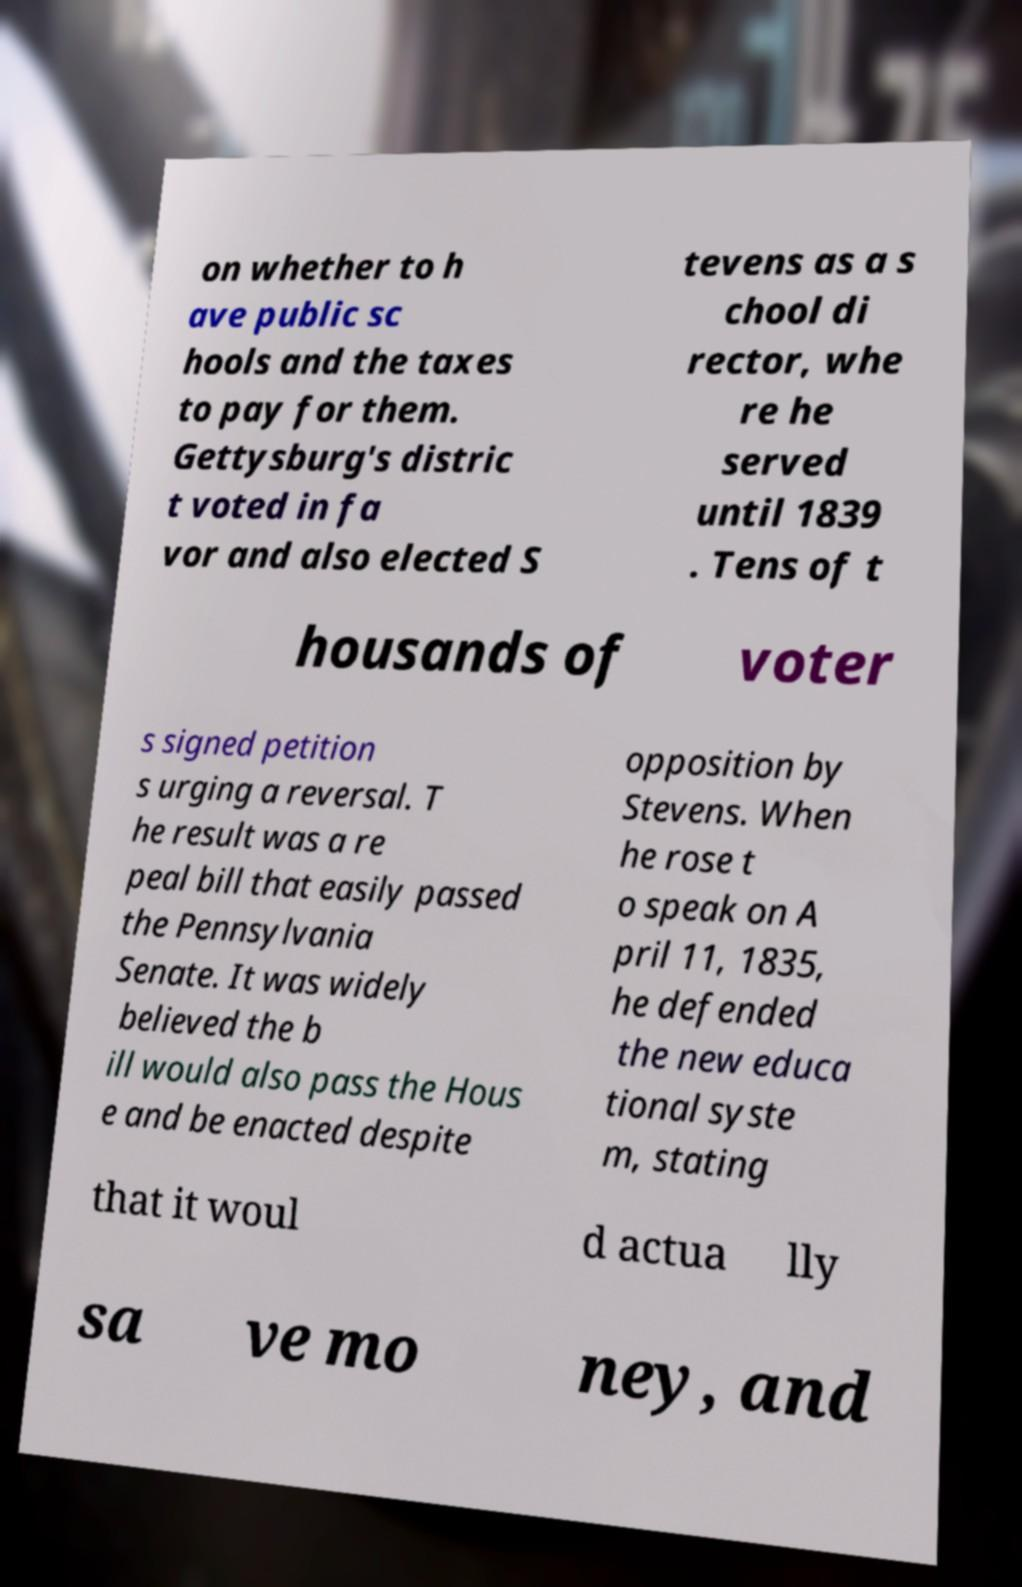Please identify and transcribe the text found in this image. on whether to h ave public sc hools and the taxes to pay for them. Gettysburg's distric t voted in fa vor and also elected S tevens as a s chool di rector, whe re he served until 1839 . Tens of t housands of voter s signed petition s urging a reversal. T he result was a re peal bill that easily passed the Pennsylvania Senate. It was widely believed the b ill would also pass the Hous e and be enacted despite opposition by Stevens. When he rose t o speak on A pril 11, 1835, he defended the new educa tional syste m, stating that it woul d actua lly sa ve mo ney, and 